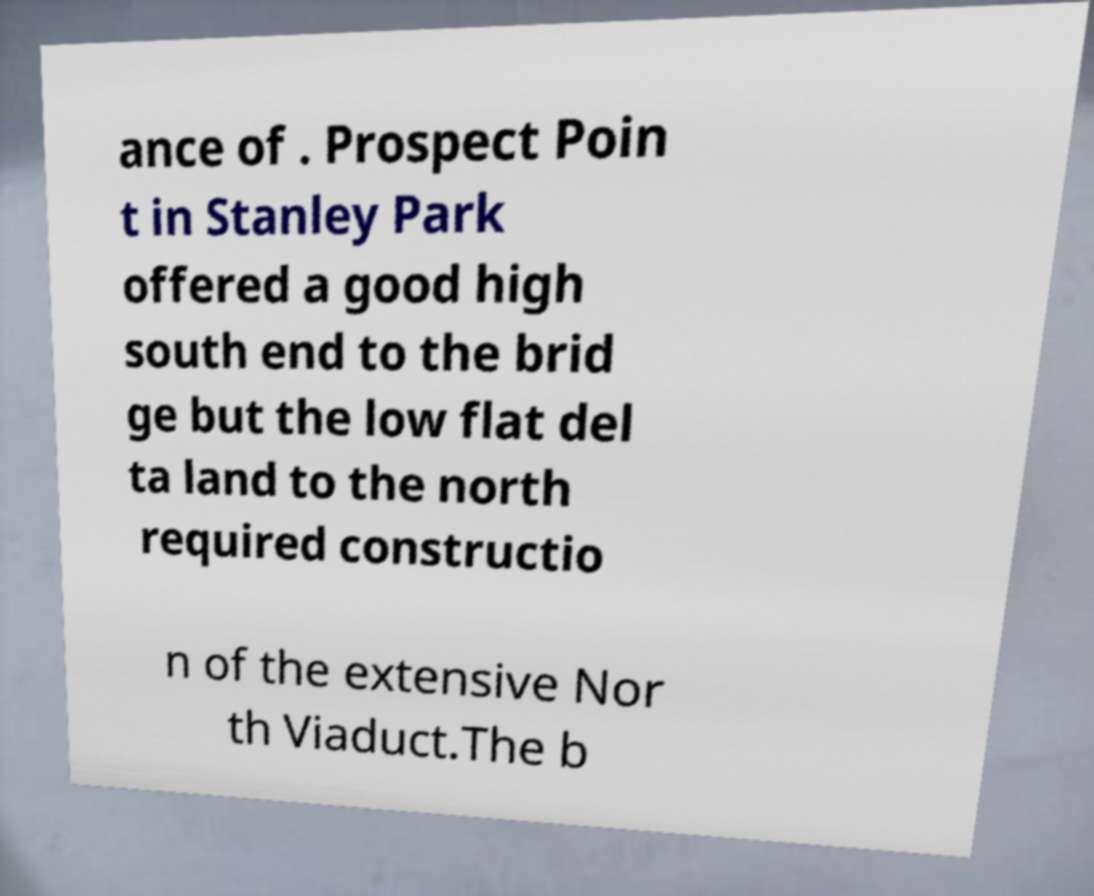Please identify and transcribe the text found in this image. ance of . Prospect Poin t in Stanley Park offered a good high south end to the brid ge but the low flat del ta land to the north required constructio n of the extensive Nor th Viaduct.The b 